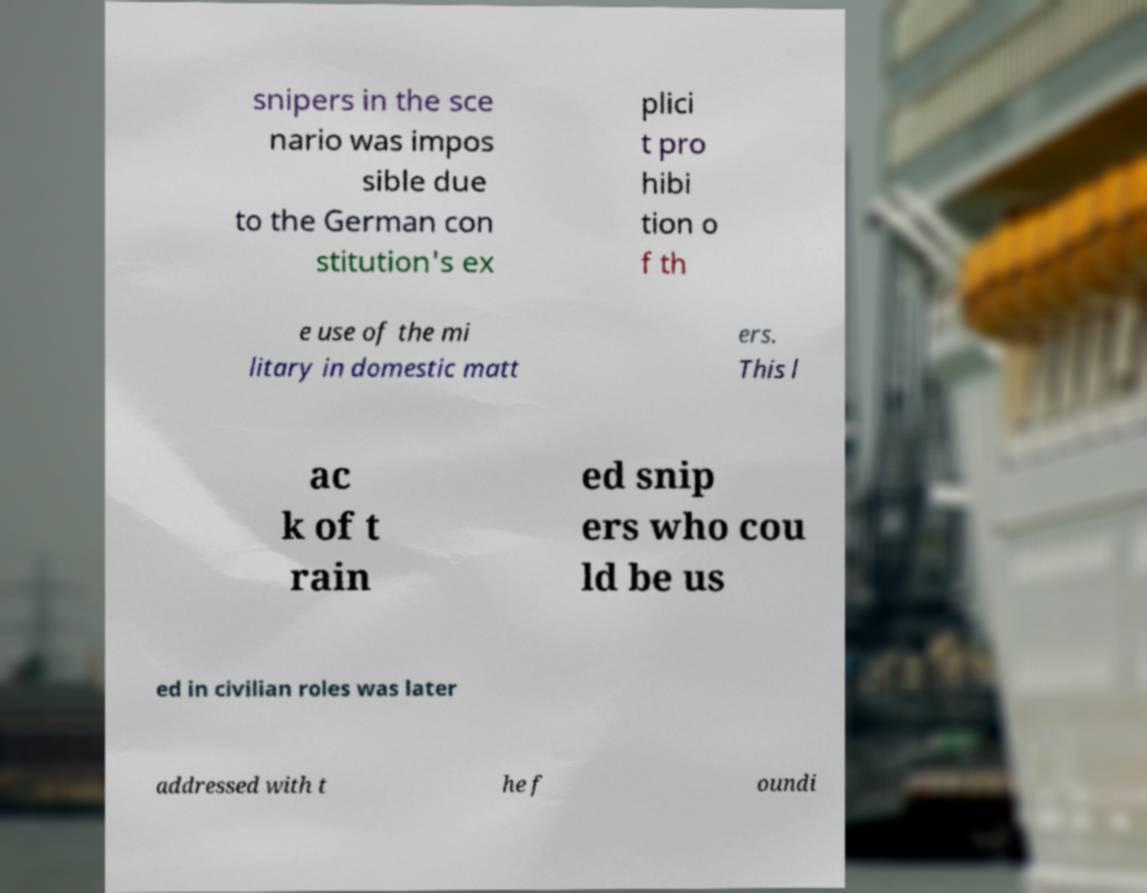For documentation purposes, I need the text within this image transcribed. Could you provide that? snipers in the sce nario was impos sible due to the German con stitution's ex plici t pro hibi tion o f th e use of the mi litary in domestic matt ers. This l ac k of t rain ed snip ers who cou ld be us ed in civilian roles was later addressed with t he f oundi 